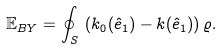Convert formula to latex. <formula><loc_0><loc_0><loc_500><loc_500>\mathbb { E } _ { B Y } = \oint _ { S } \, \left ( k _ { 0 } ( \hat { e } _ { 1 } ) - k ( \hat { e } _ { 1 } ) \right ) \varrho .</formula> 